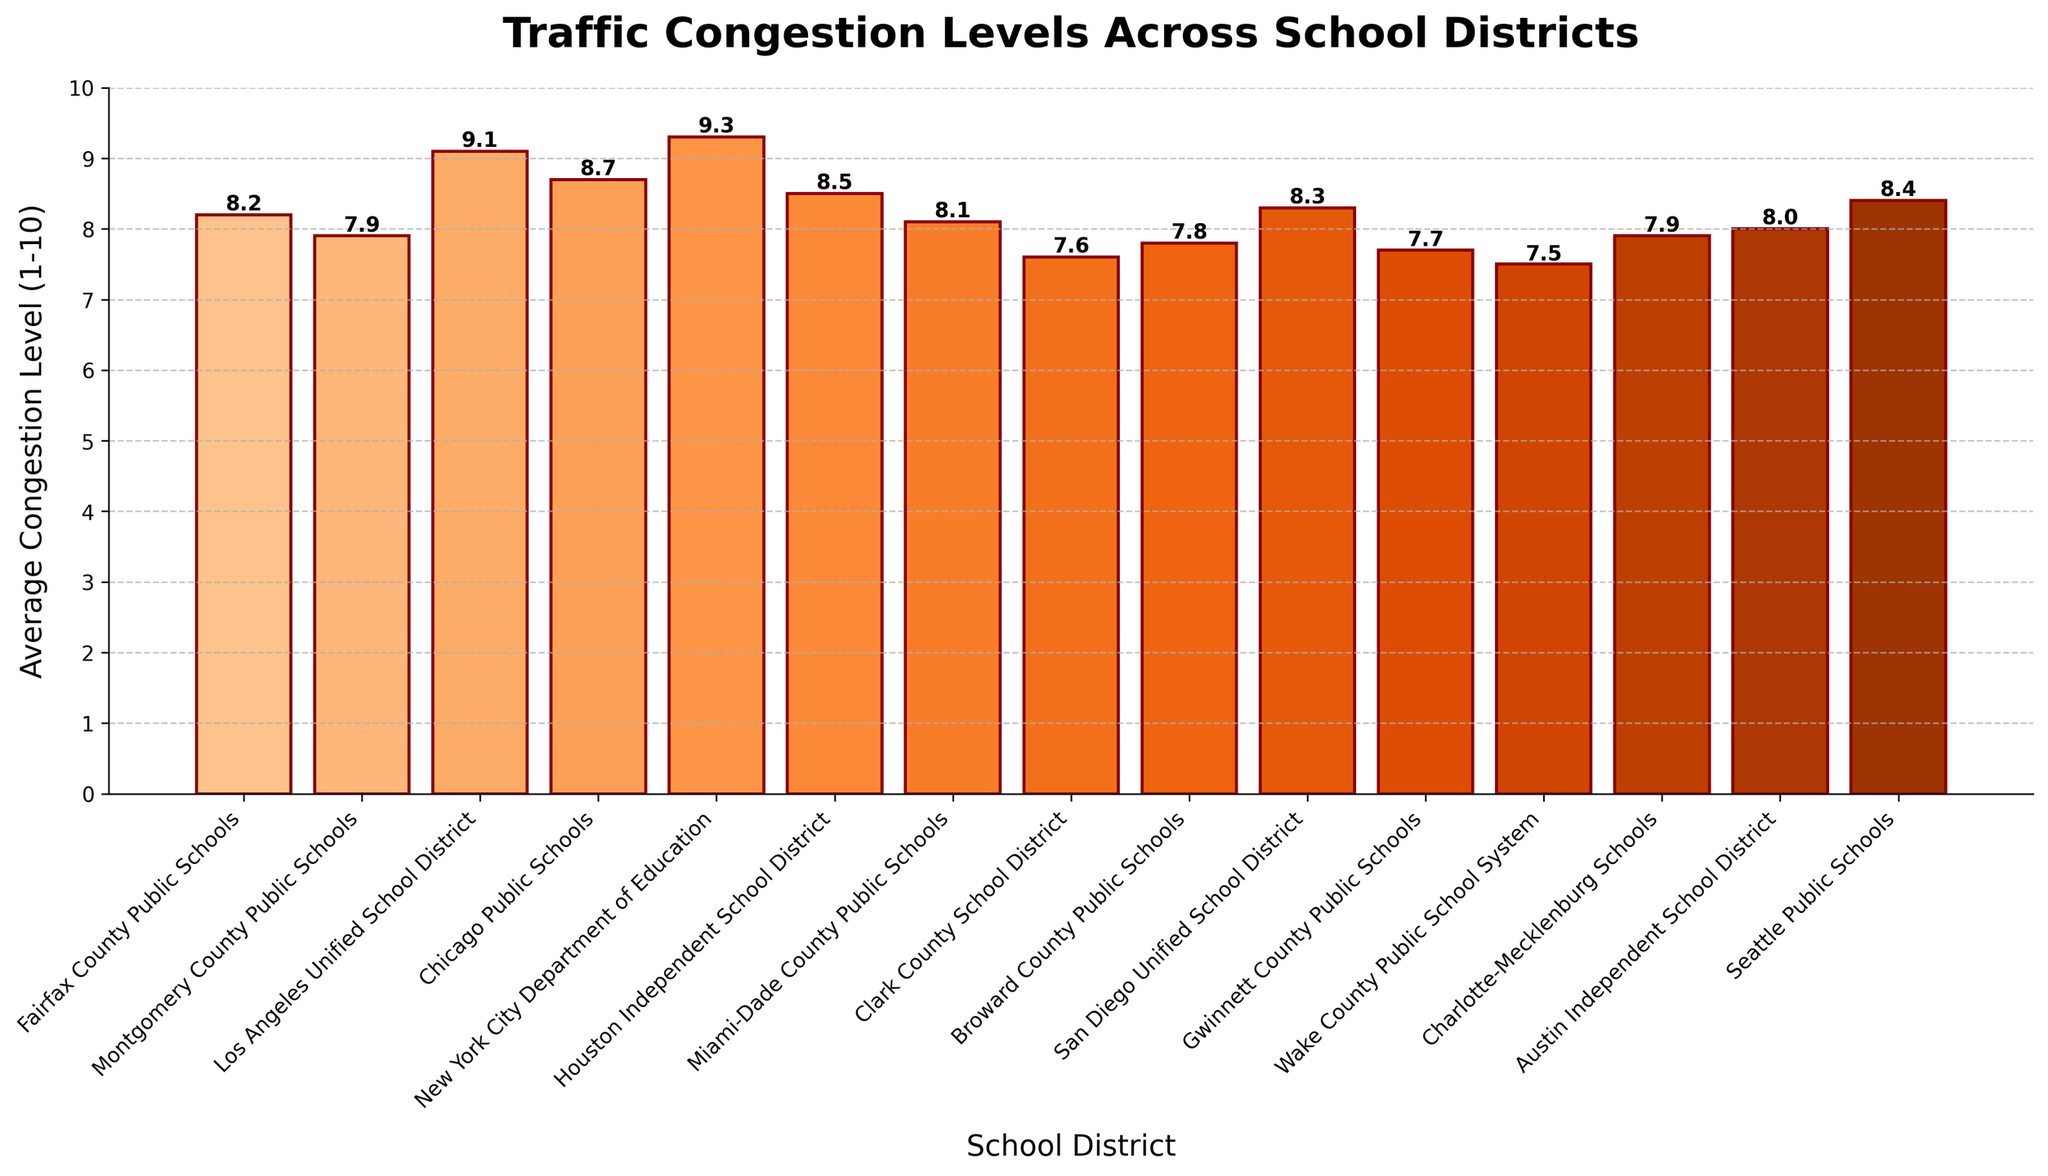Which school district has the highest average congestion level? The highest average congestion level can be identified by looking for the tallest bar in the plot. New York City Department of Education has the highest bar.
Answer: New York City Department of Education What is the difference in average congestion level between New York City Department of Education and Fairfax County Public Schools? New York City Department of Education has an average congestion level of 9.3, while Fairfax County Public Schools has 8.2. The difference is 9.3 - 8.2.
Answer: 1.1 Which school districts have an average congestion level above 8.5? Bars that exceed the 8.5 mark represent districts with higher congestion levels. This includes New York City Department of Education, Los Angeles Unified School District, Chicago Public Schools, and Houston Independent School District.
Answer: New York City Department of Education, Los Angeles Unified School District, Chicago Public Schools, Houston Independent School District How many school districts have an average congestion level below 8? Count the number of bars that are shorter than the 8 mark on the y-axis. There are 7 school districts below this mark.
Answer: 7 What is the combined average congestion level of Montgomery County Public Schools and Charlotte-Mecklenburg Schools? Add the average congestion levels of the two districts: 7.9 + 7.9.
Answer: 15.8 Which schools have an average congestion level roughly equal to 8? Bars with heights close to the 8 mark are for Miami-Dade County Public Schools and Austin Independent School District, each with an average congestion level of 8.0.
Answer: Miami-Dade County Public Schools, Austin Independent School District How much higher is the average congestion level of San Diego Unified School District compared to Gwinnett County Public Schools? The average congestion level for San Diego Unified School District is 8.3, while for Gwinnett County Public Schools, it is 7.7. The difference is 8.3 - 7.7.
Answer: 0.6 Which school district has the lowest average congestion level? The shortest bar indicates the school district with the lowest congestion level. Wake County Public School System has the lowest average congestion level.
Answer: Wake County Public School System What is the average congestion level of the top three most congested school districts? The top three most congested districts are New York City Department of Education (9.3), Los Angeles Unified School District (9.1), and Chicago Public Schools (8.7). The average is (9.3 + 9.1 + 8.7) / 3.
Answer: 9.03 Which school district has a higher congestion level, Fairfax County Public Schools or San Diego Unified School District? Compare the heights of the bars for these districts. San Diego Unified School District has a higher congestion level at 8.3 compared to 8.2 for Fairfax County Public Schools.
Answer: San Diego Unified School District 